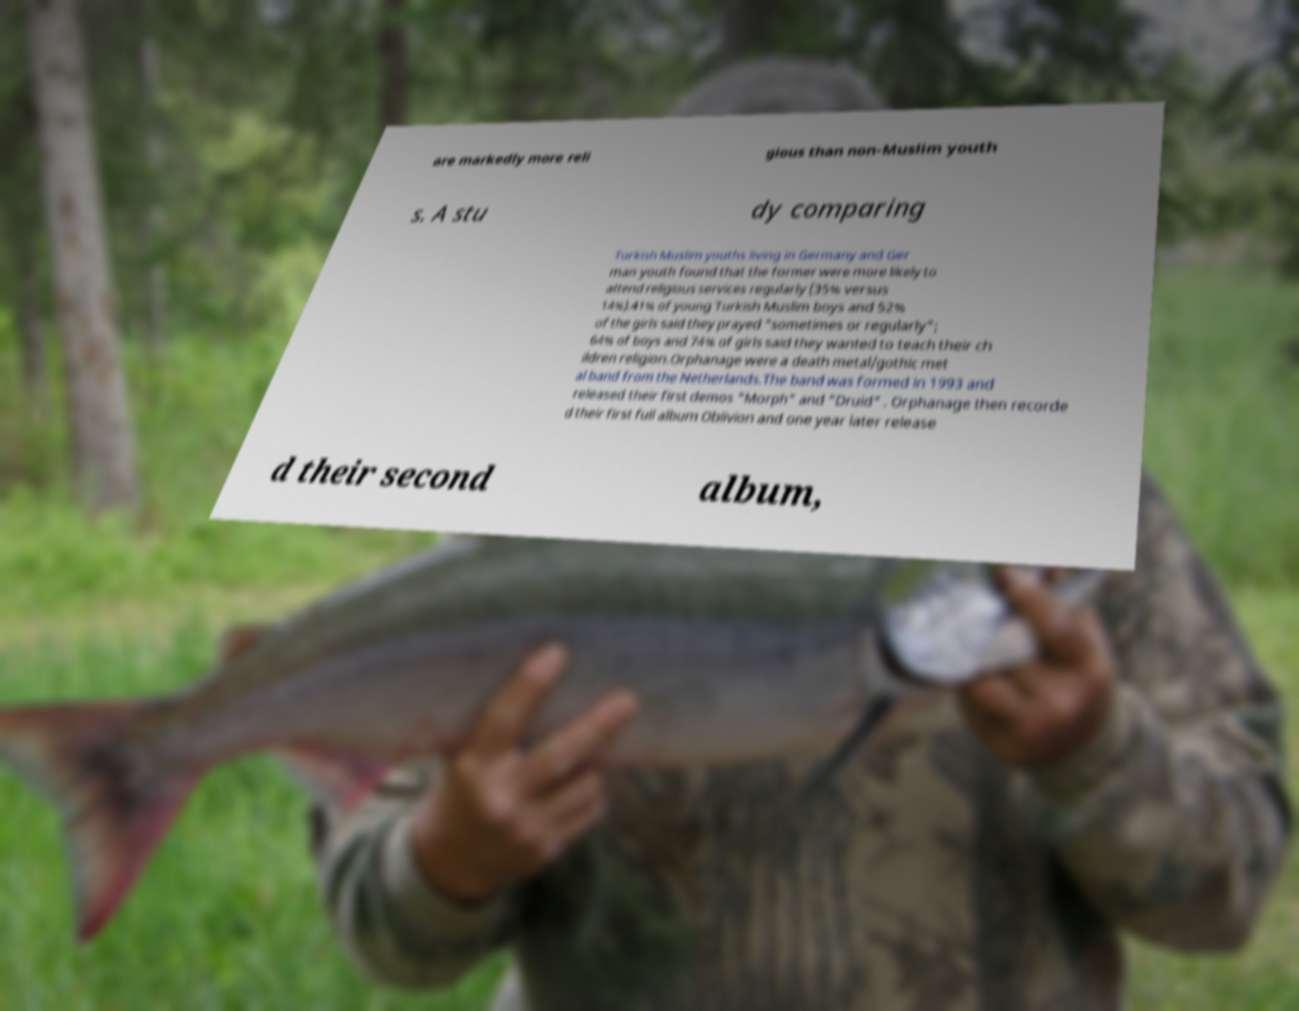I need the written content from this picture converted into text. Can you do that? are markedly more reli gious than non-Muslim youth s. A stu dy comparing Turkish Muslim youths living in Germany and Ger man youth found that the former were more likely to attend religious services regularly (35% versus 14%).41% of young Turkish Muslim boys and 52% of the girls said they prayed "sometimes or regularly"; 64% of boys and 74% of girls said they wanted to teach their ch ildren religion.Orphanage were a death metal/gothic met al band from the Netherlands.The band was formed in 1993 and released their first demos "Morph" and "Druid" . Orphanage then recorde d their first full album Oblivion and one year later release d their second album, 